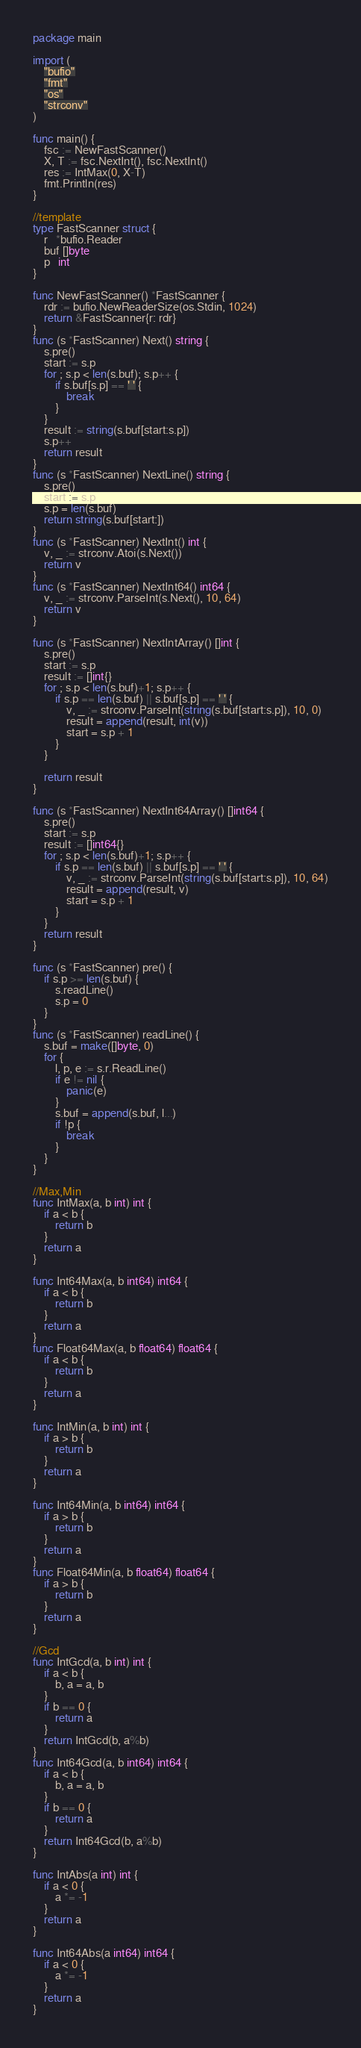<code> <loc_0><loc_0><loc_500><loc_500><_Go_>package main

import (
	"bufio"
	"fmt"
	"os"
	"strconv"
)

func main() {
	fsc := NewFastScanner()
	X, T := fsc.NextInt(), fsc.NextInt()
	res := IntMax(0, X-T)
	fmt.Println(res)
}

//template
type FastScanner struct {
	r   *bufio.Reader
	buf []byte
	p   int
}

func NewFastScanner() *FastScanner {
	rdr := bufio.NewReaderSize(os.Stdin, 1024)
	return &FastScanner{r: rdr}
}
func (s *FastScanner) Next() string {
	s.pre()
	start := s.p
	for ; s.p < len(s.buf); s.p++ {
		if s.buf[s.p] == ' ' {
			break
		}
	}
	result := string(s.buf[start:s.p])
	s.p++
	return result
}
func (s *FastScanner) NextLine() string {
	s.pre()
	start := s.p
	s.p = len(s.buf)
	return string(s.buf[start:])
}
func (s *FastScanner) NextInt() int {
	v, _ := strconv.Atoi(s.Next())
	return v
}
func (s *FastScanner) NextInt64() int64 {
	v, _ := strconv.ParseInt(s.Next(), 10, 64)
	return v
}

func (s *FastScanner) NextIntArray() []int {
	s.pre()
	start := s.p
	result := []int{}
	for ; s.p < len(s.buf)+1; s.p++ {
		if s.p == len(s.buf) || s.buf[s.p] == ' ' {
			v, _ := strconv.ParseInt(string(s.buf[start:s.p]), 10, 0)
			result = append(result, int(v))
			start = s.p + 1
		}
	}

	return result
}

func (s *FastScanner) NextInt64Array() []int64 {
	s.pre()
	start := s.p
	result := []int64{}
	for ; s.p < len(s.buf)+1; s.p++ {
		if s.p == len(s.buf) || s.buf[s.p] == ' ' {
			v, _ := strconv.ParseInt(string(s.buf[start:s.p]), 10, 64)
			result = append(result, v)
			start = s.p + 1
		}
	}
	return result
}

func (s *FastScanner) pre() {
	if s.p >= len(s.buf) {
		s.readLine()
		s.p = 0
	}
}
func (s *FastScanner) readLine() {
	s.buf = make([]byte, 0)
	for {
		l, p, e := s.r.ReadLine()
		if e != nil {
			panic(e)
		}
		s.buf = append(s.buf, l...)
		if !p {
			break
		}
	}
}

//Max,Min
func IntMax(a, b int) int {
	if a < b {
		return b
	}
	return a
}

func Int64Max(a, b int64) int64 {
	if a < b {
		return b
	}
	return a
}
func Float64Max(a, b float64) float64 {
	if a < b {
		return b
	}
	return a
}

func IntMin(a, b int) int {
	if a > b {
		return b
	}
	return a
}

func Int64Min(a, b int64) int64 {
	if a > b {
		return b
	}
	return a
}
func Float64Min(a, b float64) float64 {
	if a > b {
		return b
	}
	return a
}

//Gcd
func IntGcd(a, b int) int {
	if a < b {
		b, a = a, b
	}
	if b == 0 {
		return a
	}
	return IntGcd(b, a%b)
}
func Int64Gcd(a, b int64) int64 {
	if a < b {
		b, a = a, b
	}
	if b == 0 {
		return a
	}
	return Int64Gcd(b, a%b)
}

func IntAbs(a int) int {
	if a < 0 {
		a *= -1
	}
	return a
}

func Int64Abs(a int64) int64 {
	if a < 0 {
		a *= -1
	}
	return a
}
</code> 